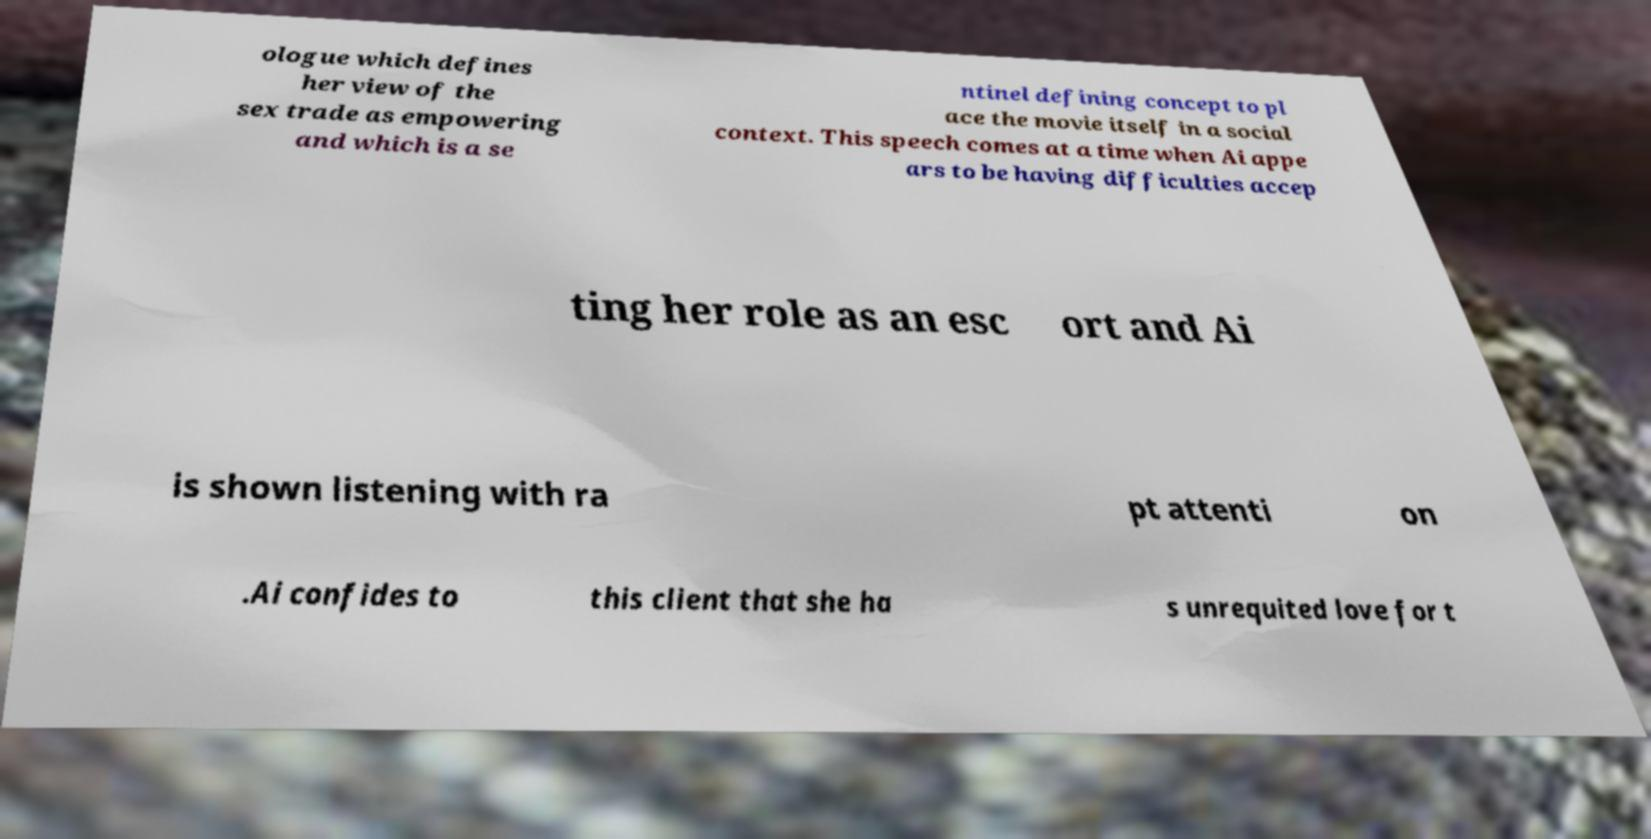Please identify and transcribe the text found in this image. ologue which defines her view of the sex trade as empowering and which is a se ntinel defining concept to pl ace the movie itself in a social context. This speech comes at a time when Ai appe ars to be having difficulties accep ting her role as an esc ort and Ai is shown listening with ra pt attenti on .Ai confides to this client that she ha s unrequited love for t 